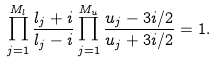<formula> <loc_0><loc_0><loc_500><loc_500>\prod _ { j = 1 } ^ { M _ { l } } \frac { l _ { j } + i } { l _ { j } - i } \prod _ { j = 1 } ^ { M _ { u } } \frac { u _ { j } - 3 i / 2 } { u _ { j } + 3 i / 2 } = 1 .</formula> 